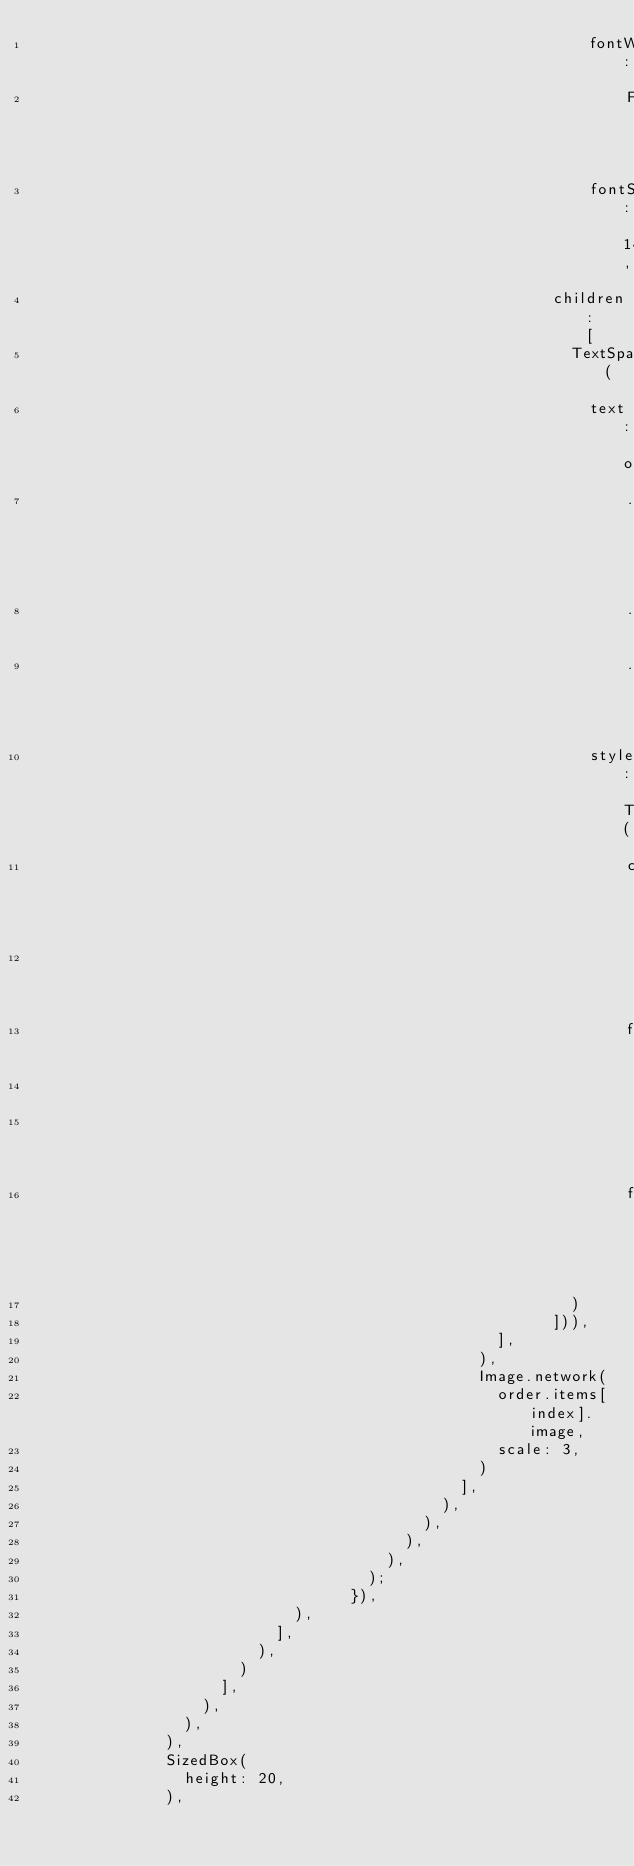<code> <loc_0><loc_0><loc_500><loc_500><_Dart_>                                                            fontWeight:
                                                                FontWeight.w600,
                                                            fontSize: 14),
                                                        children: [
                                                          TextSpan(
                                                            text: order
                                                                .items[index]
                                                                .quantity
                                                                .toString(),
                                                            style: TextStyle(
                                                                color: Colors
                                                                    .black,
                                                                fontWeight:
                                                                    FontWeight
                                                                        .w800,
                                                                fontSize: 14),
                                                          )
                                                        ])),
                                                  ],
                                                ),
                                                Image.network(
                                                  order.items[index].image,
                                                  scale: 3,
                                                )
                                              ],
                                            ),
                                          ),
                                        ),
                                      ),
                                    );
                                  }),
                            ),
                          ],
                        ),
                      )
                    ],
                  ),
                ),
              ),
              SizedBox(
                height: 20,
              ),</code> 